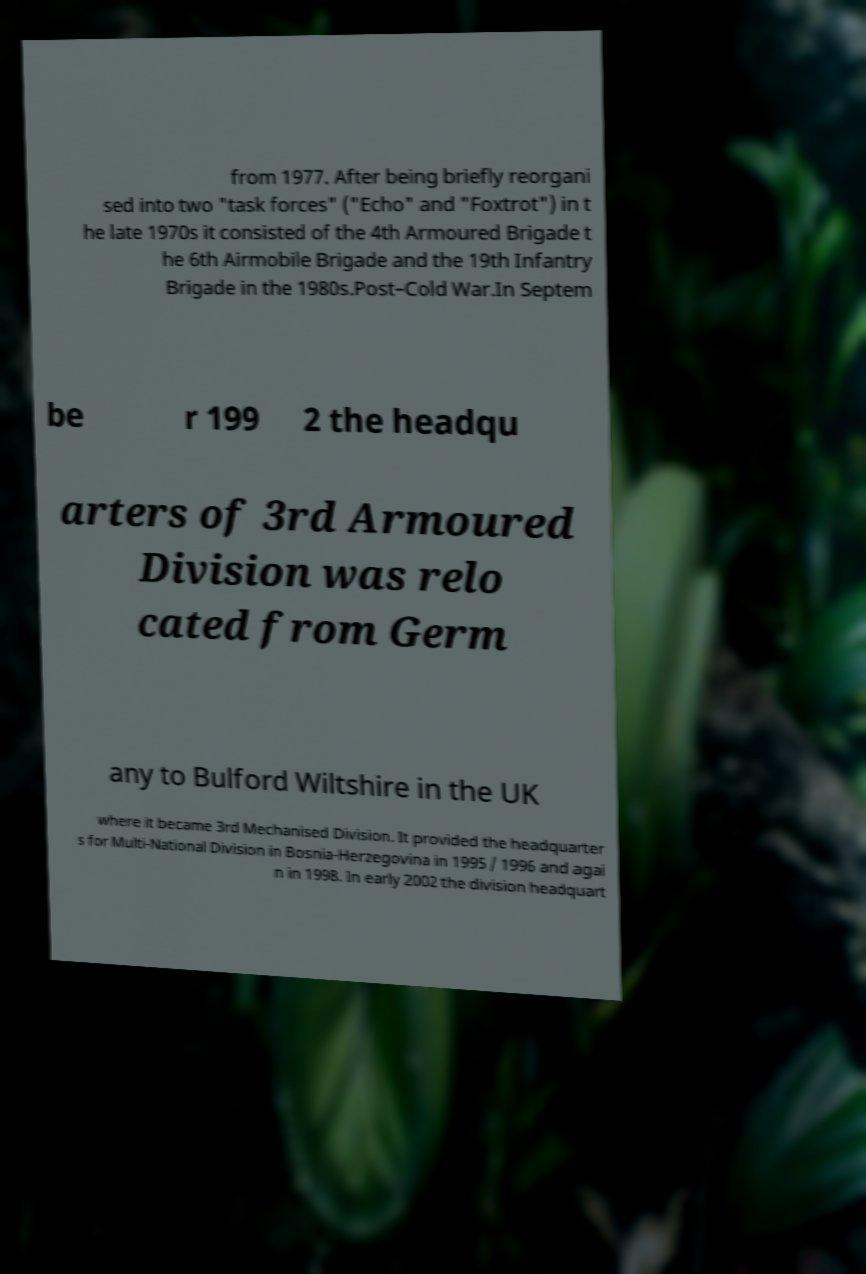I need the written content from this picture converted into text. Can you do that? from 1977. After being briefly reorgani sed into two "task forces" ("Echo" and "Foxtrot") in t he late 1970s it consisted of the 4th Armoured Brigade t he 6th Airmobile Brigade and the 19th Infantry Brigade in the 1980s.Post–Cold War.In Septem be r 199 2 the headqu arters of 3rd Armoured Division was relo cated from Germ any to Bulford Wiltshire in the UK where it became 3rd Mechanised Division. It provided the headquarter s for Multi-National Division in Bosnia-Herzegovina in 1995 / 1996 and agai n in 1998. In early 2002 the division headquart 